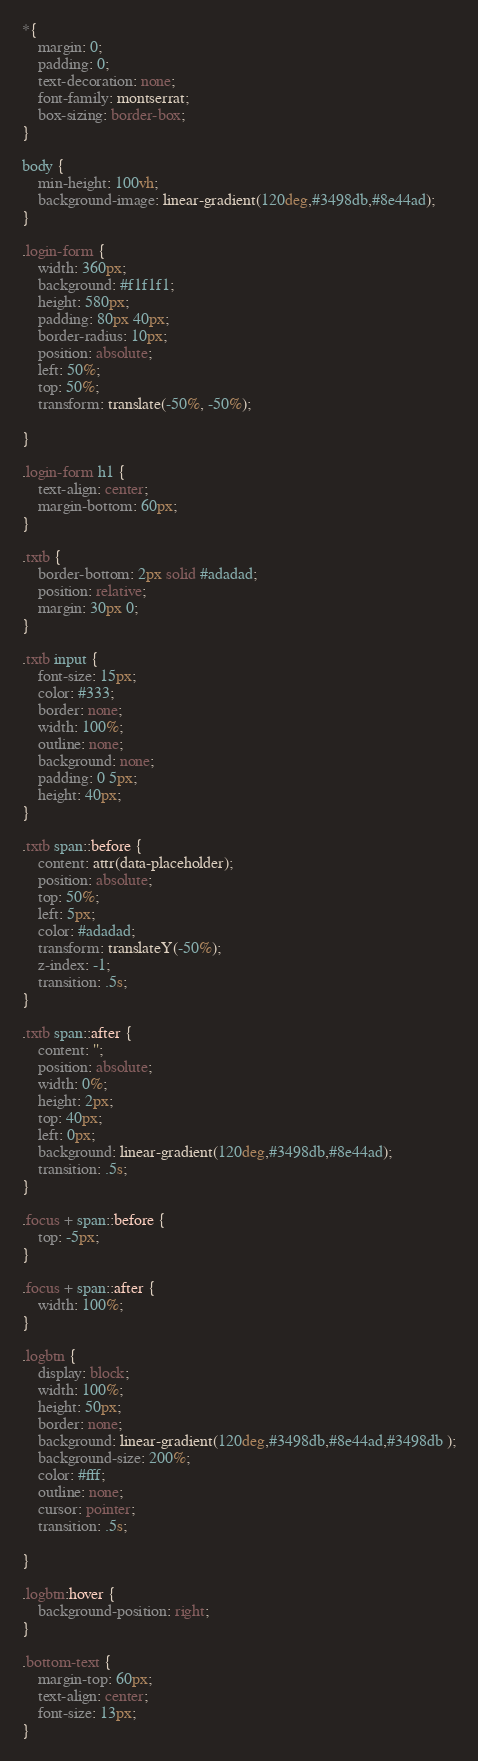<code> <loc_0><loc_0><loc_500><loc_500><_CSS_>*{
    margin: 0;
    padding: 0;
    text-decoration: none;
    font-family: montserrat;
    box-sizing: border-box;
}

body {
    min-height: 100vh;
    background-image: linear-gradient(120deg,#3498db,#8e44ad);
}

.login-form {
    width: 360px;
    background: #f1f1f1;
    height: 580px;
    padding: 80px 40px;
    border-radius: 10px;
    position: absolute;
    left: 50%;
    top: 50%;
    transform: translate(-50%, -50%);

}

.login-form h1 {
    text-align: center;
    margin-bottom: 60px;
}

.txtb {
    border-bottom: 2px solid #adadad;
    position: relative;
    margin: 30px 0;
}

.txtb input {
    font-size: 15px;
    color: #333;
    border: none;
    width: 100%;
    outline: none;
    background: none;
    padding: 0 5px;
    height: 40px;
}

.txtb span::before {
    content: attr(data-placeholder);
    position: absolute;
    top: 50%;
    left: 5px;
    color: #adadad;
    transform: translateY(-50%);
    z-index: -1;
    transition: .5s;
}

.txtb span::after {
    content: '';
    position: absolute;
    width: 0%;
    height: 2px;
    top: 40px;
    left: 0px;
    background: linear-gradient(120deg,#3498db,#8e44ad);
    transition: .5s;
}

.focus + span::before {
    top: -5px;
}

.focus + span::after {
    width: 100%;  
}

.logbtn {
    display: block;
    width: 100%;
    height: 50px;
    border: none;
    background: linear-gradient(120deg,#3498db,#8e44ad,#3498db );
    background-size: 200%;
    color: #fff;
    outline: none;
    cursor: pointer;
    transition: .5s;

}

.logbtn:hover {
    background-position: right;
}

.bottom-text {
    margin-top: 60px;
    text-align: center;
    font-size: 13px;
}


</code> 